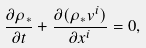<formula> <loc_0><loc_0><loc_500><loc_500>\frac { \partial \rho _ { * } } { \partial t } + \frac { \partial ( \rho _ { * } v ^ { i } ) } { \partial x ^ { i } } = 0 ,</formula> 